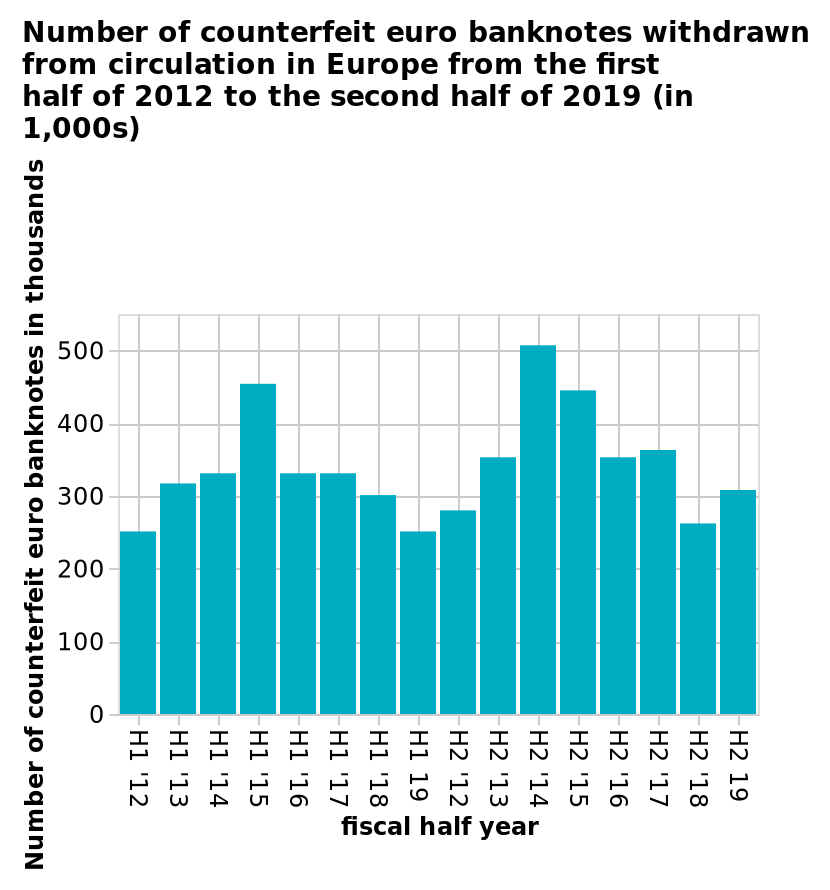<image>
please summary the statistics and relations of the chart There were two peaks of counterfeit euro banknotes withdrawn from circulation in Europe at H1, 15 and H2,14. What was the time frame of the second peak of counterfeit euro banknotes in Europe?  The second peak occurred in H2, 14. What is the time range covered by the bar diagram?  The bar diagram covers the period from the first half of 2012 to the second half of 2019. 